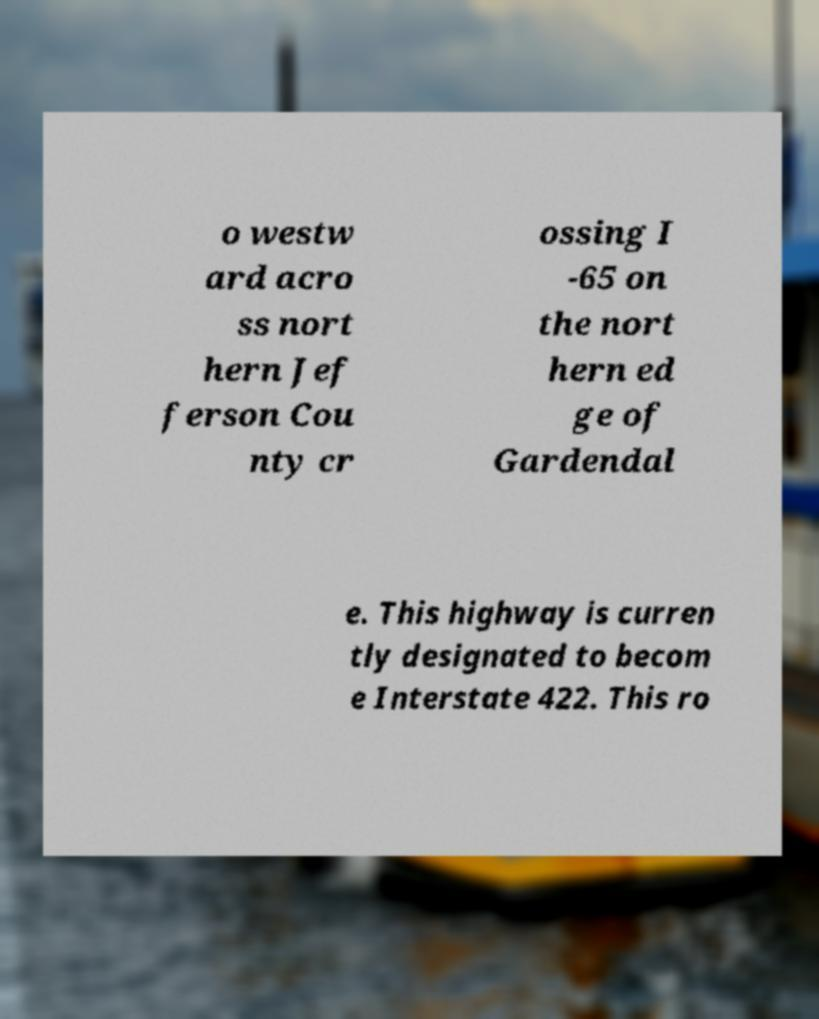Can you read and provide the text displayed in the image?This photo seems to have some interesting text. Can you extract and type it out for me? o westw ard acro ss nort hern Jef ferson Cou nty cr ossing I -65 on the nort hern ed ge of Gardendal e. This highway is curren tly designated to becom e Interstate 422. This ro 